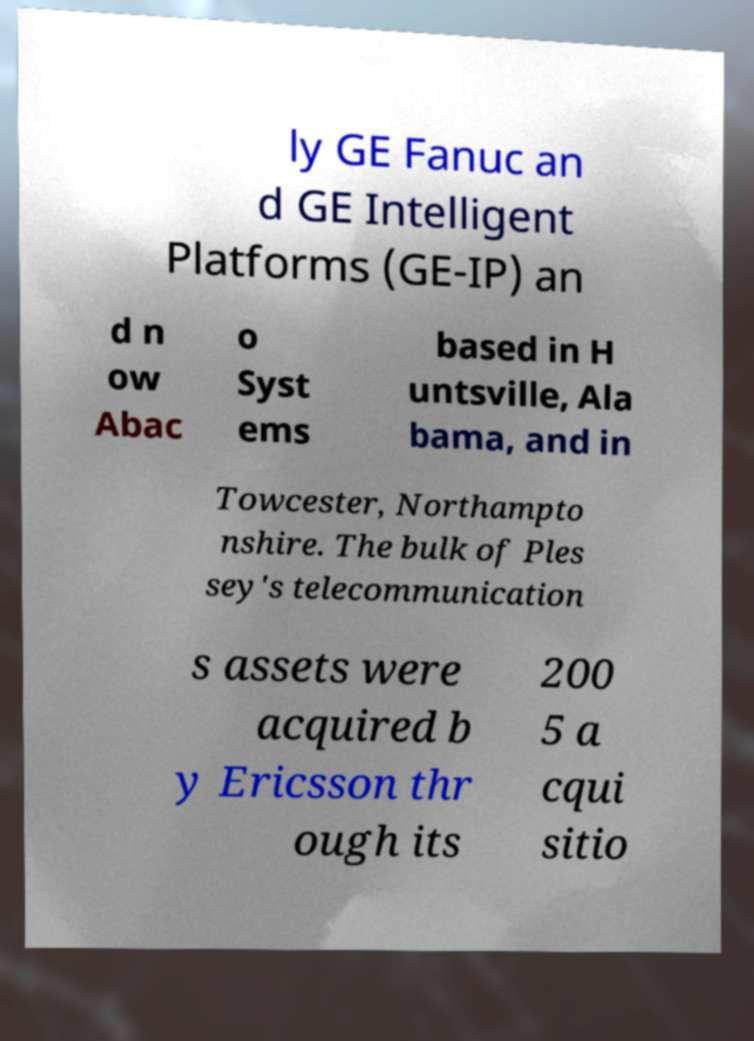What messages or text are displayed in this image? I need them in a readable, typed format. ly GE Fanuc an d GE Intelligent Platforms (GE-IP) an d n ow Abac o Syst ems based in H untsville, Ala bama, and in Towcester, Northampto nshire. The bulk of Ples sey's telecommunication s assets were acquired b y Ericsson thr ough its 200 5 a cqui sitio 